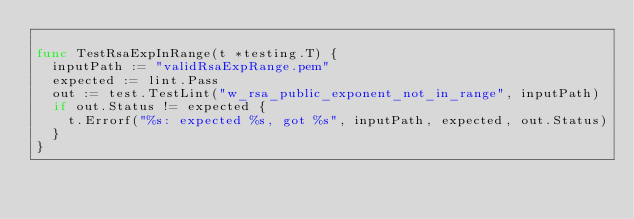<code> <loc_0><loc_0><loc_500><loc_500><_Go_>
func TestRsaExpInRange(t *testing.T) {
	inputPath := "validRsaExpRange.pem"
	expected := lint.Pass
	out := test.TestLint("w_rsa_public_exponent_not_in_range", inputPath)
	if out.Status != expected {
		t.Errorf("%s: expected %s, got %s", inputPath, expected, out.Status)
	}
}
</code> 